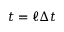<formula> <loc_0><loc_0><loc_500><loc_500>t = \ell \Delta t</formula> 